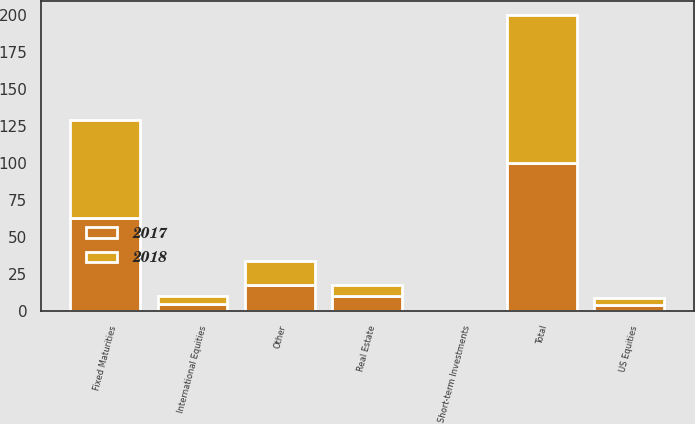Convert chart. <chart><loc_0><loc_0><loc_500><loc_500><stacked_bar_chart><ecel><fcel>US Equities<fcel>International Equities<fcel>Fixed Maturities<fcel>Short-term Investments<fcel>Real Estate<fcel>Other<fcel>Total<nl><fcel>2017<fcel>4<fcel>5<fcel>63<fcel>0<fcel>10<fcel>18<fcel>100<nl><fcel>2018<fcel>5<fcel>5<fcel>66<fcel>0<fcel>8<fcel>16<fcel>100<nl></chart> 